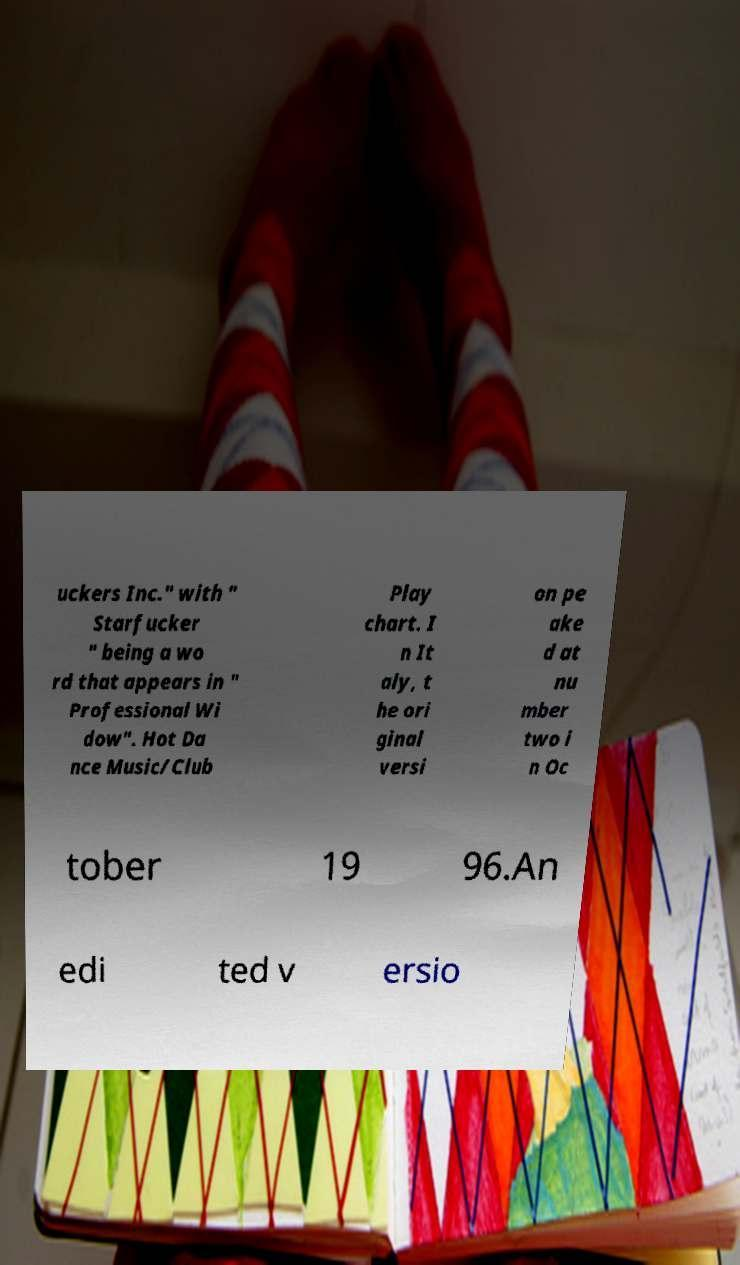For documentation purposes, I need the text within this image transcribed. Could you provide that? uckers Inc." with " Starfucker " being a wo rd that appears in " Professional Wi dow". Hot Da nce Music/Club Play chart. I n It aly, t he ori ginal versi on pe ake d at nu mber two i n Oc tober 19 96.An edi ted v ersio 